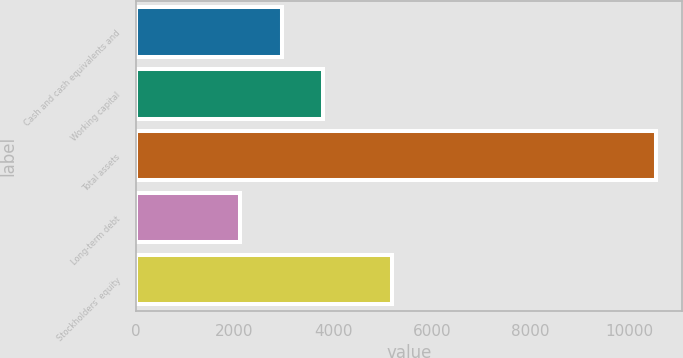<chart> <loc_0><loc_0><loc_500><loc_500><bar_chart><fcel>Cash and cash equivalents and<fcel>Working capital<fcel>Total assets<fcel>Long-term debt<fcel>Stockholders' equity<nl><fcel>2954.4<fcel>3796.8<fcel>10536<fcel>2112<fcel>5182<nl></chart> 